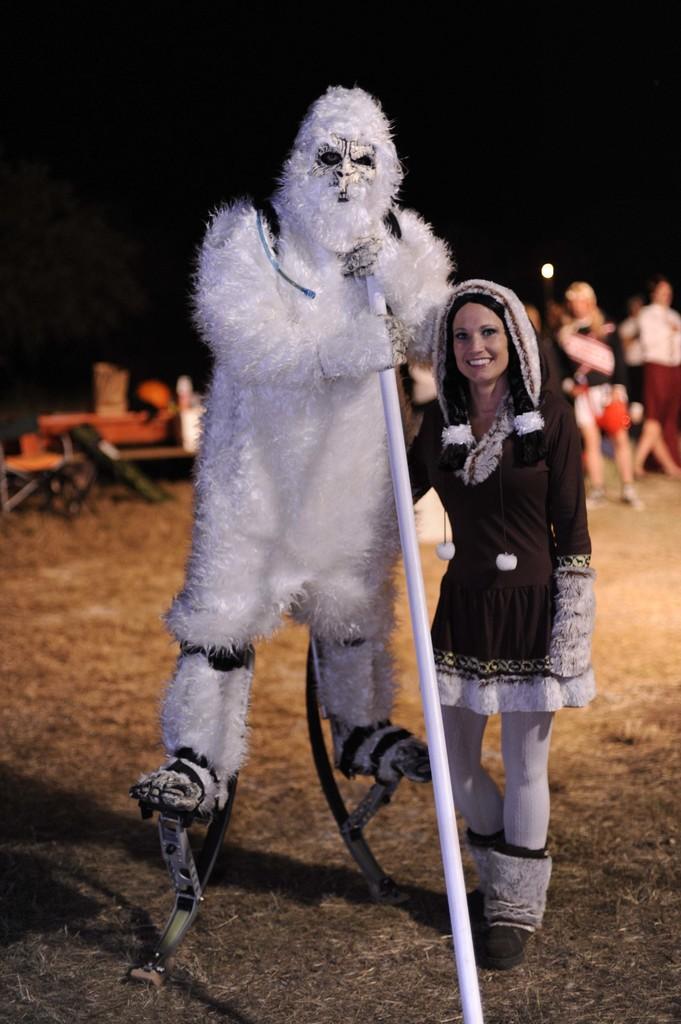In one or two sentences, can you explain what this image depicts? In this picture we can see a person wearing a costume and holding an object. We can see this person standing on the objects. There is a woman standing and smiling. We can see some grass on the ground. There are a few people, some objects and the light is visible in the background. We can see the dark view in the background. 